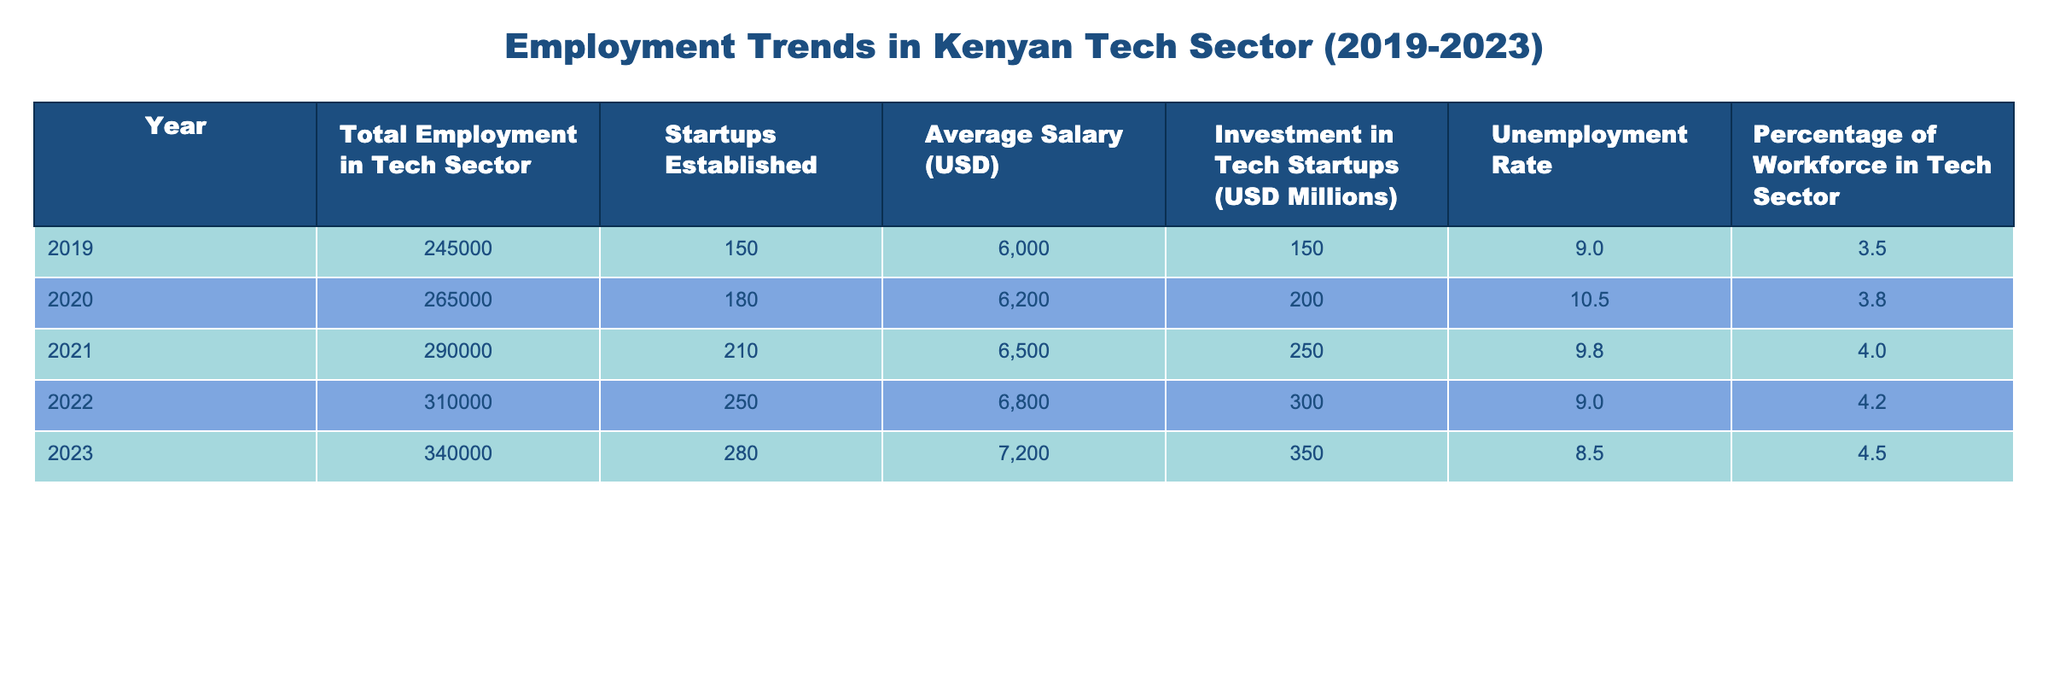What was the total employment in the tech sector in 2021? The table shows that in 2021, the total employment in the tech sector was listed as 290,000.
Answer: 290000 How many startups were established in 2023? From the table, in 2023, the number of startups established is indicated as 280.
Answer: 280 What is the percentage increase in the average salary from 2019 to 2023? The average salary in 2019 was 6,000 and in 2023 it was 7,200. The increase is calculated as (7,200 - 6,000) / 6,000 * 100 = 20%, indicating a percentage increase of 20.
Answer: 20 Is it true that the unemployment rate decreased over the five years listed? Examining the unemployment rates year by year shows: 9.0 (2019), 10.5 (2020), 9.8 (2021), 9.0 (2022), and 8.5 (2023). Since the unemployment rate decreased from 10.5 to 8.5 between 2020 and 2023, the statement is true.
Answer: Yes What was the total investment in tech startups from 2019 to 2023? To find the total investment, sum the investments for each year: 150 + 200 + 250 + 300 + 350 = 1,250 million USD. The total investment in tech startups over these years is therefore 1,250 million USD.
Answer: 1250 How does the percentage of the workforce in the tech sector in 2020 compare to 2023? For 2020, the percentage of the workforce in the tech sector was 3.8, while in 2023 it was 4.5. Thus, the percentage of the workforce in the tech sector increased from 3.8 to 4.5, signifying growth.
Answer: Increased What is the average investment in tech startups from 2019 to 2023? To calculate the average investment, sum the investments (150 + 200 + 250 + 300 + 350 = 1,250) and divide by the number of years (5). 1,250 / 5 = 250 million USD, which gives us the average investment.
Answer: 250 Which year had the highest total employment in the tech sector? By looking through the total employment data, 2023 shows a total employment of 340,000, which is higher than all previous years listed. Thus, 2023 had the highest total employment in the tech sector.
Answer: 2023 Was the number of startups established in 2022 higher than in 2020? Comparing the years, 2020 had 180 startups established, while 2022 saw a rise to 250 startups. Therefore, since 250 (2022) is greater than 180 (2020), this statement is true.
Answer: Yes 